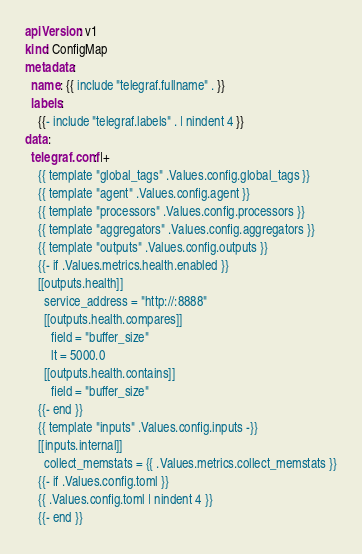Convert code to text. <code><loc_0><loc_0><loc_500><loc_500><_YAML_>apiVersion: v1
kind: ConfigMap
metadata:
  name: {{ include "telegraf.fullname" . }}
  labels:
    {{- include "telegraf.labels" . | nindent 4 }}
data:
  telegraf.conf: |+
    {{ template "global_tags" .Values.config.global_tags }}
    {{ template "agent" .Values.config.agent }}
    {{ template "processors" .Values.config.processors }}
    {{ template "aggregators" .Values.config.aggregators }}
    {{ template "outputs" .Values.config.outputs }}
    {{- if .Values.metrics.health.enabled }}
    [[outputs.health]]
      service_address = "http://:8888"
      [[outputs.health.compares]]
        field = "buffer_size"
        lt = 5000.0
      [[outputs.health.contains]]
        field = "buffer_size"
    {{- end }}
    {{ template "inputs" .Values.config.inputs -}}
    [[inputs.internal]]
      collect_memstats = {{ .Values.metrics.collect_memstats }}
    {{- if .Values.config.toml }}
    {{ .Values.config.toml | nindent 4 }}
    {{- end }}
</code> 